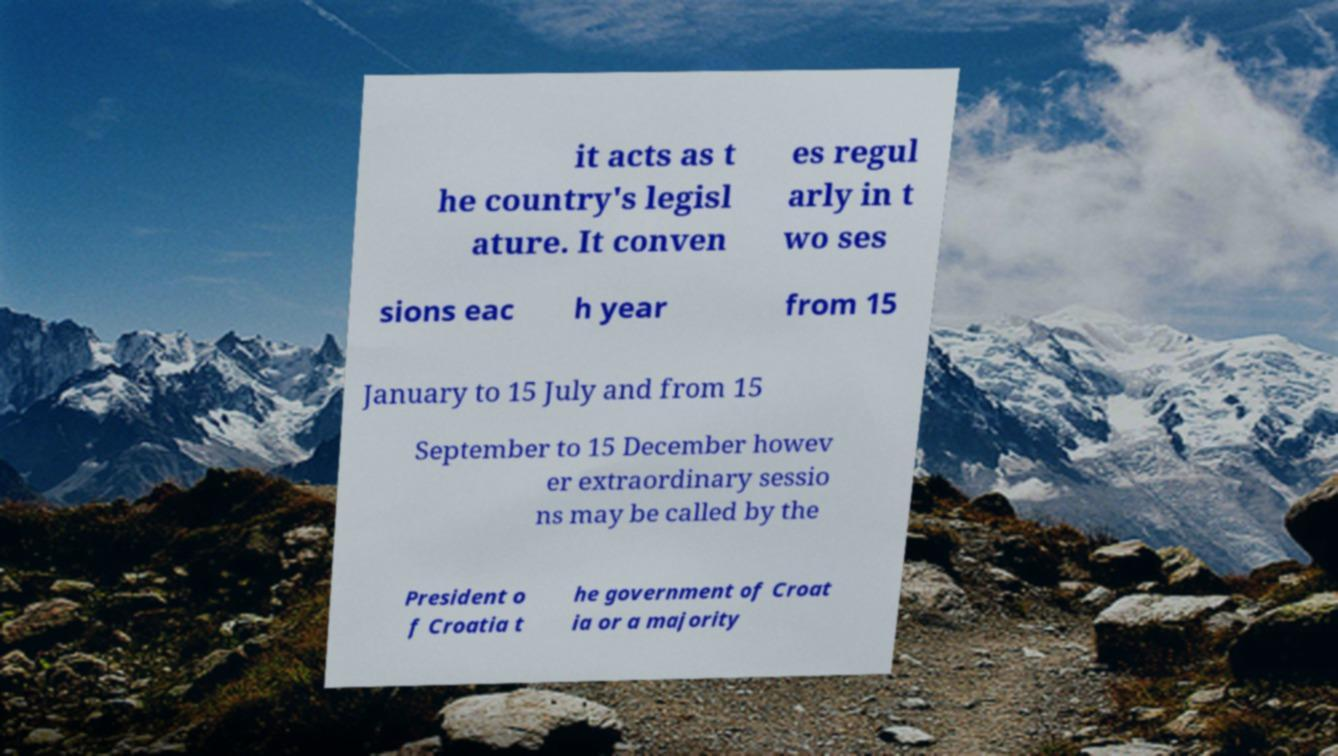For documentation purposes, I need the text within this image transcribed. Could you provide that? it acts as t he country's legisl ature. It conven es regul arly in t wo ses sions eac h year from 15 January to 15 July and from 15 September to 15 December howev er extraordinary sessio ns may be called by the President o f Croatia t he government of Croat ia or a majority 